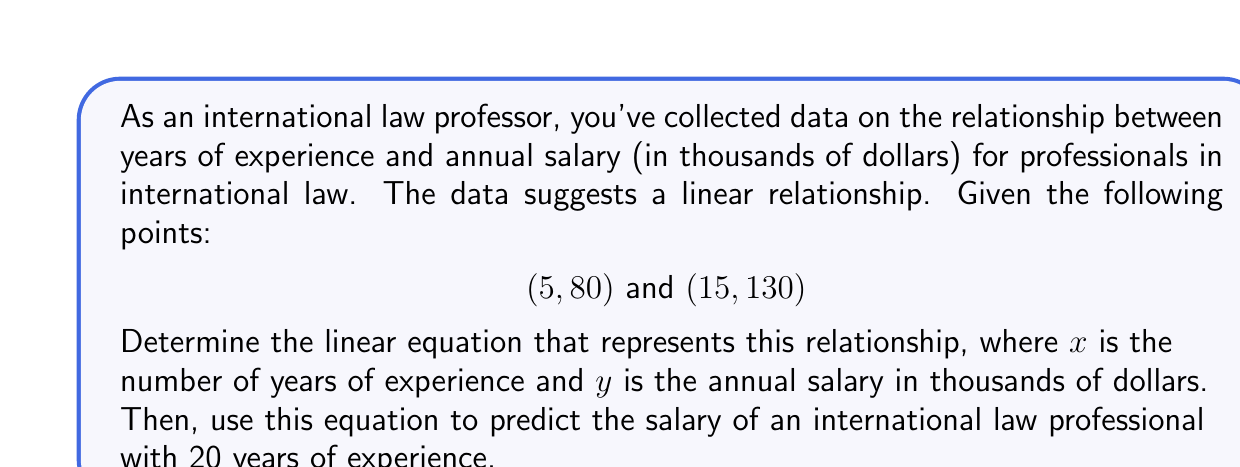Can you solve this math problem? To solve this problem, we'll follow these steps:

1. Find the slope of the line using the two given points.
2. Use the slope and one of the points to find the y-intercept.
3. Write the equation in slope-intercept form.
4. Use the equation to predict the salary for 20 years of experience.

Step 1: Find the slope
The slope formula is:
$$ m = \frac{y_2 - y_1}{x_2 - x_1} $$

Using the points (5, 80) and (15, 130):
$$ m = \frac{130 - 80}{15 - 5} = \frac{50}{10} = 5 $$

Step 2: Find the y-intercept
Use the point-slope form of a line: $y - y_1 = m(x - x_1)$
Let's use the point (5, 80):

$$ y - 80 = 5(x - 5) $$
$$ y = 5x - 25 + 80 $$
$$ y = 5x + 55 $$

Step 3: Write the equation
The equation in slope-intercept form is:
$$ y = 5x + 55 $$

Where $y$ is the salary in thousands of dollars and $x$ is the years of experience.

Step 4: Predict salary for 20 years of experience
Substitute $x = 20$ into the equation:
$$ y = 5(20) + 55 = 100 + 55 = 155 $$

Therefore, the predicted salary for an international law professional with 20 years of experience is $155,000.
Answer: The linear equation is $y = 5x + 55$, where $y$ is the salary in thousands of dollars and $x$ is the years of experience. The predicted salary for an international law professional with 20 years of experience is $155,000. 